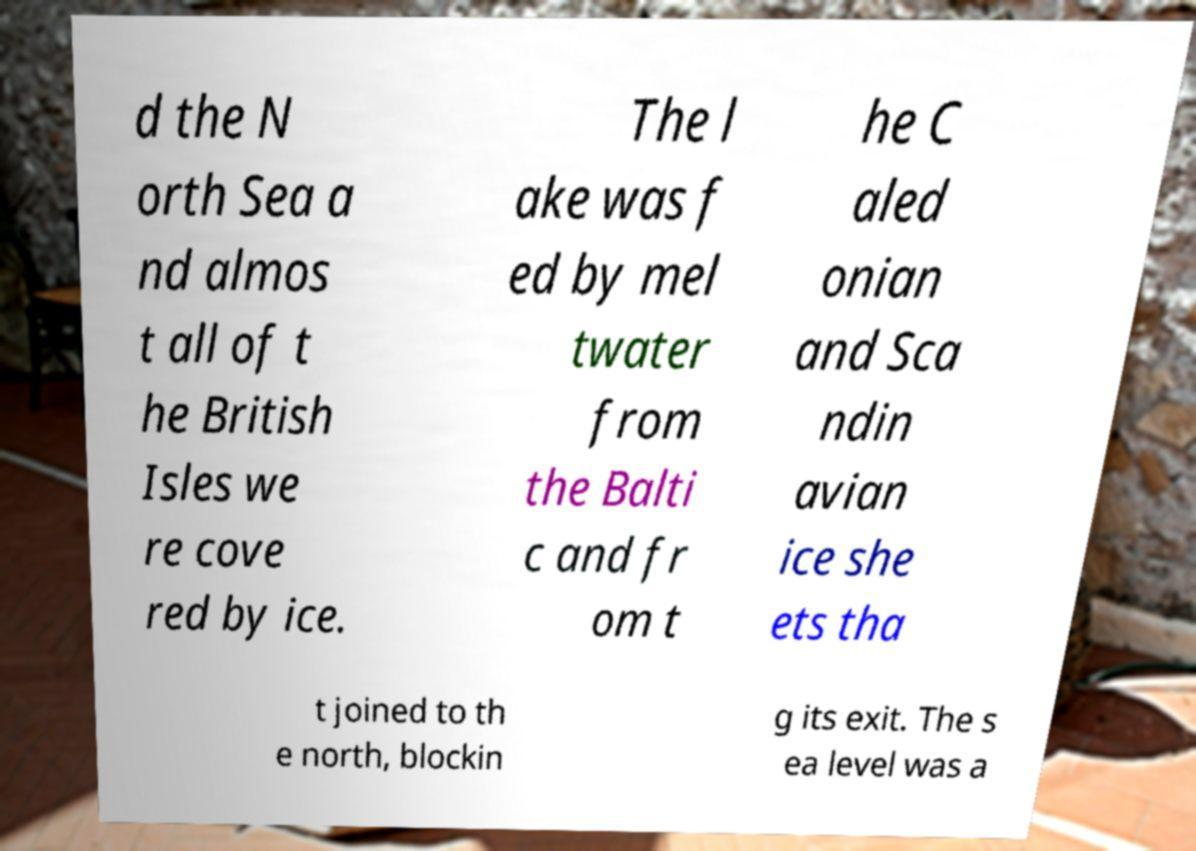Please read and relay the text visible in this image. What does it say? d the N orth Sea a nd almos t all of t he British Isles we re cove red by ice. The l ake was f ed by mel twater from the Balti c and fr om t he C aled onian and Sca ndin avian ice she ets tha t joined to th e north, blockin g its exit. The s ea level was a 